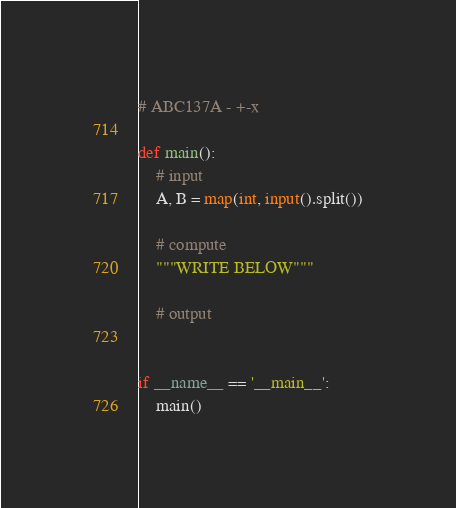<code> <loc_0><loc_0><loc_500><loc_500><_Python_># ABC137A - +-x

def main():
    # input
    A, B = map(int, input().split())

    # compute
    """WRITE BELOW"""

    # output


if __name__ == '__main__':
    main()
</code> 